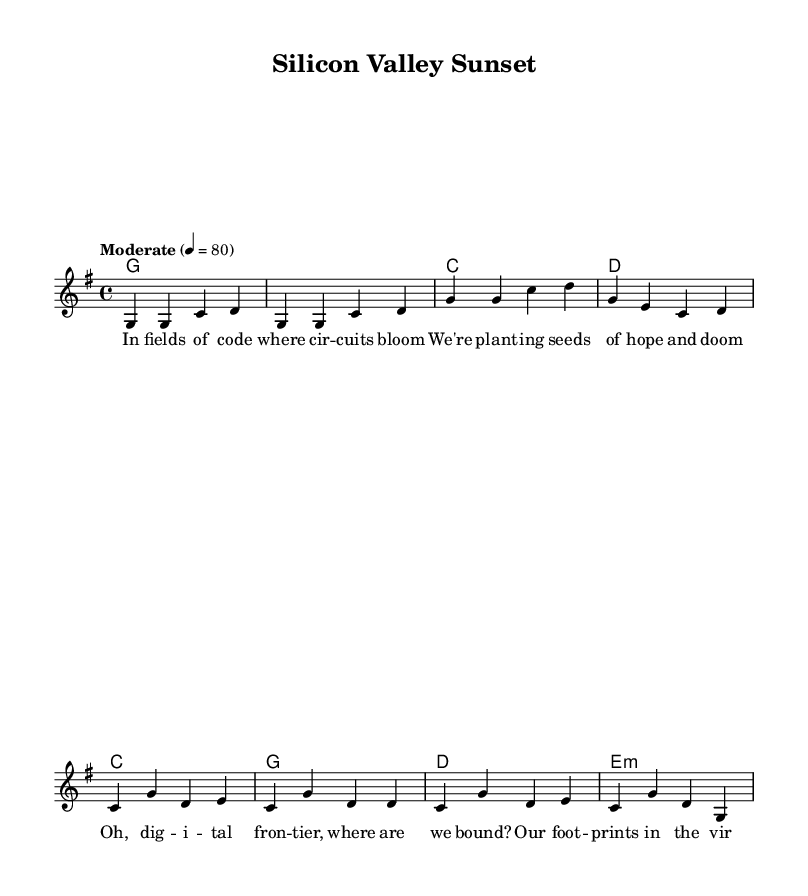What is the key signature of this music? The key signature is G major, which includes one sharp (F#). You can identify the key signature by looking at the beginning of the staff where the sharps or flats are indicated.
Answer: G major What is the time signature of this piece? The time signature is 4/4, which means there are four beats in each measure and the quarter note gets one beat. This can be seen at the beginning of the sheet music right after the key signature.
Answer: 4/4 What is the tempo marking for this piece? The tempo marking is "Moderate," indicating a moderately paced tempo for performance. This is generally noted above the staff at the start of the piece.
Answer: Moderate How many measures are in the verse? There are four measures in the verse section of the song. This can be determined by counting the grouped vertical lines on the staff which denote the end of each measure.
Answer: Four What chord follows the first line of the verse? The chord following the first line of the verse is G major. You can find this by looking at the chord symbols placed above the melody notes in the score.
Answer: G What identifies this piece as a country-folk fusion song? The lyrical content reflects themes of technology and nature, merging traditional country storytelling with contemporary issues. The lyrics explore the complexities of digital life, a hallmark of country-folk fusion.
Answer: Themes of technology and nature How does the chorus differ structurally from the verse? The chorus consists of four measures, with varied melodic patterns and different chord progressions compared to the verse. This contrast is typical in songwriting, emphasizing the emotional core of the song.
Answer: Different melodic patterns 